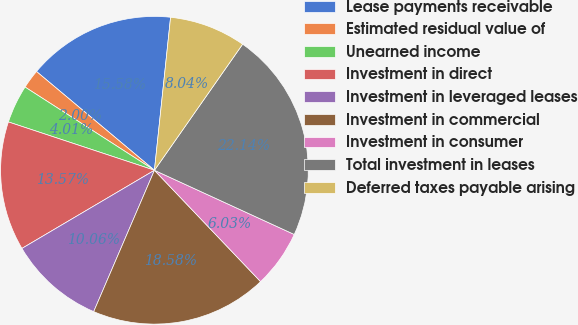Convert chart. <chart><loc_0><loc_0><loc_500><loc_500><pie_chart><fcel>Lease payments receivable<fcel>Estimated residual value of<fcel>Unearned income<fcel>Investment in direct<fcel>Investment in leveraged leases<fcel>Investment in commercial<fcel>Investment in consumer<fcel>Total investment in leases<fcel>Deferred taxes payable arising<nl><fcel>15.58%<fcel>2.0%<fcel>4.01%<fcel>13.57%<fcel>10.06%<fcel>18.58%<fcel>6.03%<fcel>22.14%<fcel>8.04%<nl></chart> 